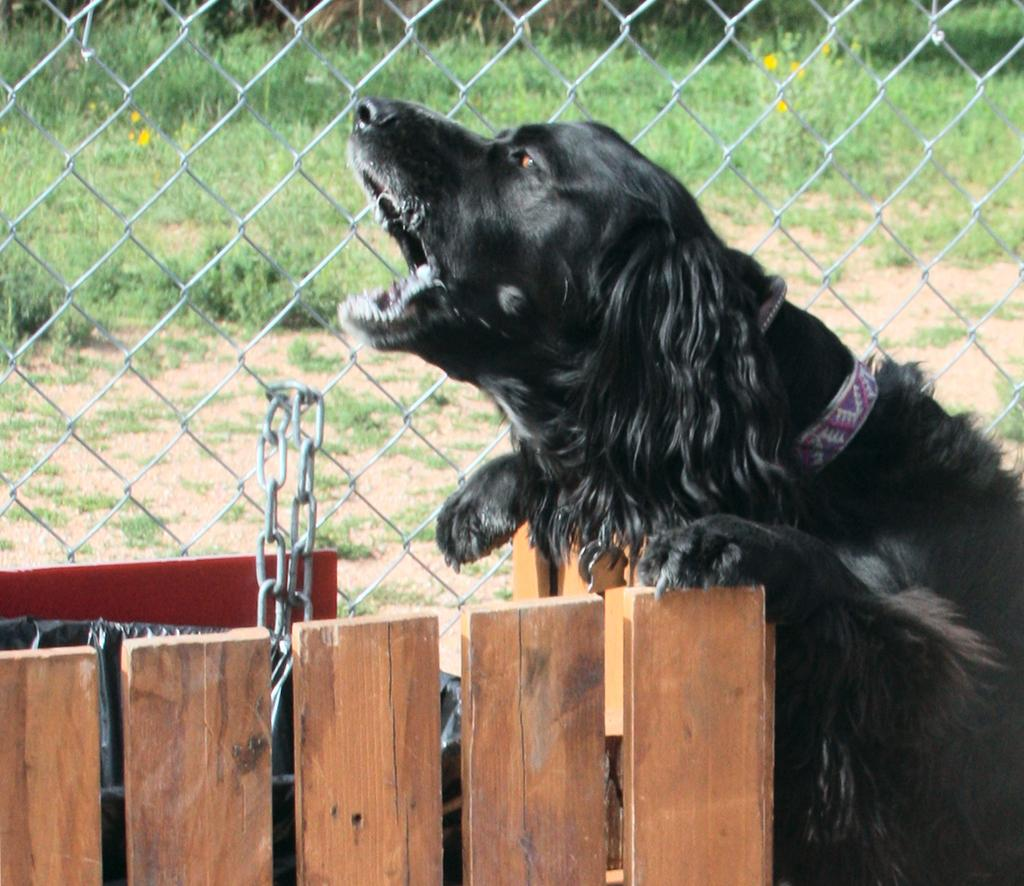What animal can be seen in the image? There is a dog in the image. Where is the dog located in relation to the wooden box? The dog is at a wooden box in the image. What can be seen in the background of the image? There is fencing and grass in the background of the image. What type of throat lozenges can be seen in the image? There are no throat lozenges present in the image; it features a dog at a wooden box with fencing and grass in the background. 